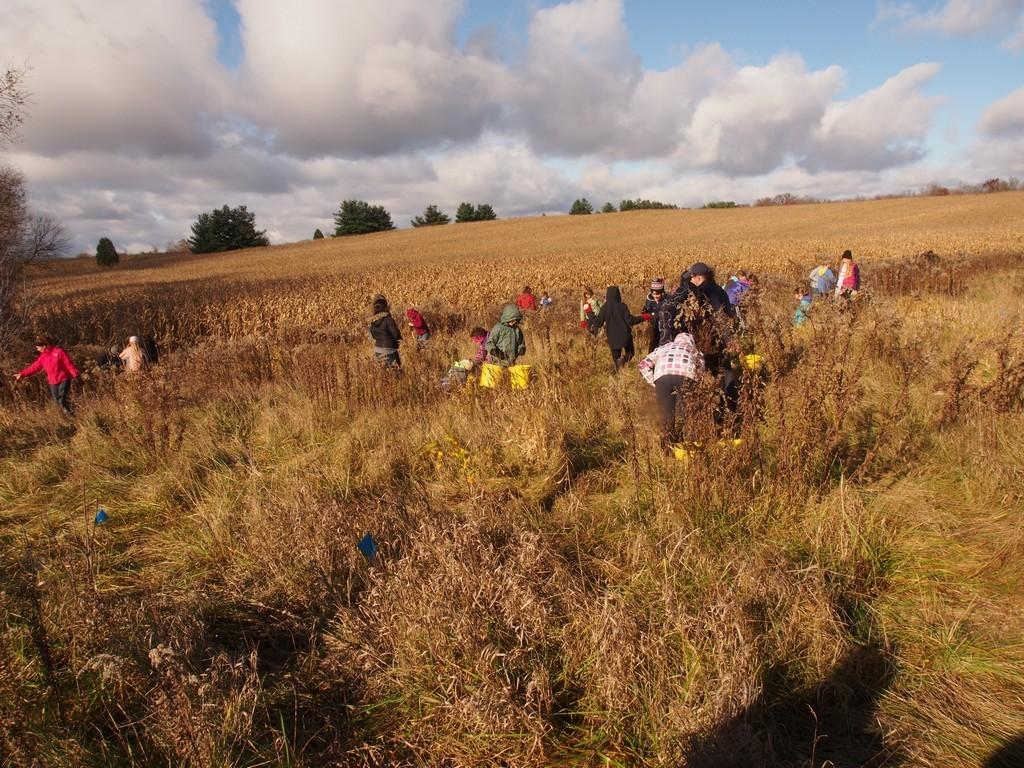What type of vegetation is visible in the image? There is grass in the image. What else can be seen in the image besides the grass? There are people standing in the image. What is visible in the background of the image? There are trees and the sky in the background of the image. What can be seen in the sky in the image? Clouds are present in the sky. Where is the drum located in the image? There is no drum present in the image. What type of table can be seen in the image? There is no table present in the image. 